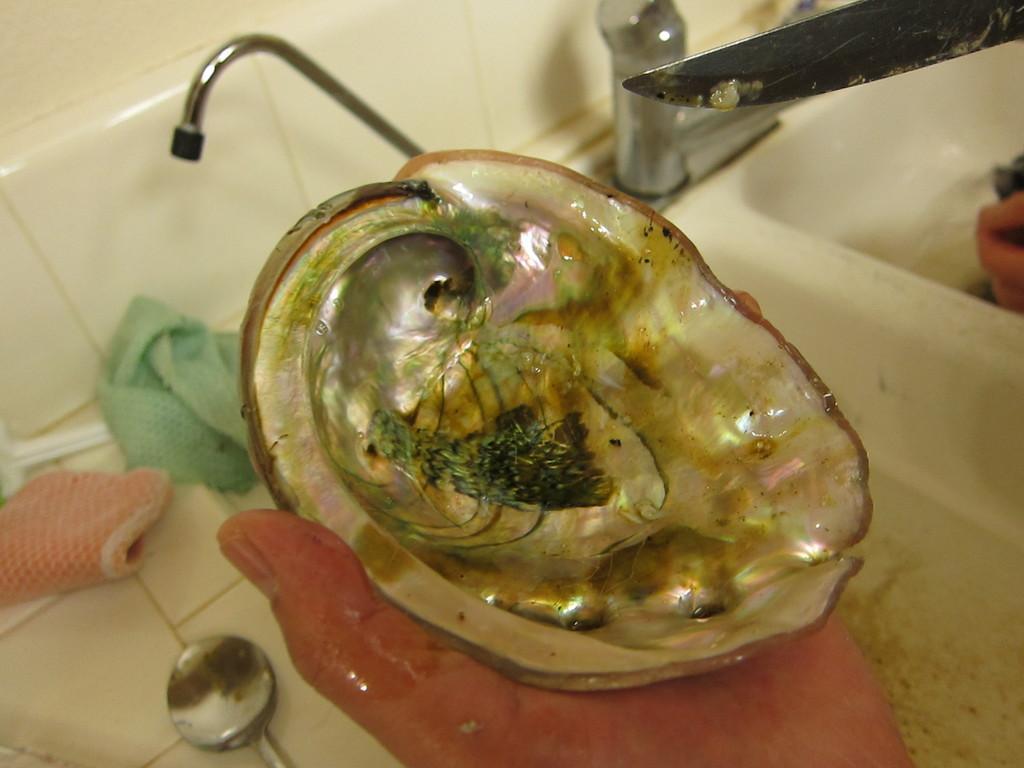Can you describe this image briefly? In the image we can see a human hand holding the seashell. Here we can see the water tap, wash basin, a spoon and napkins. We can even see the knife and the wall. 